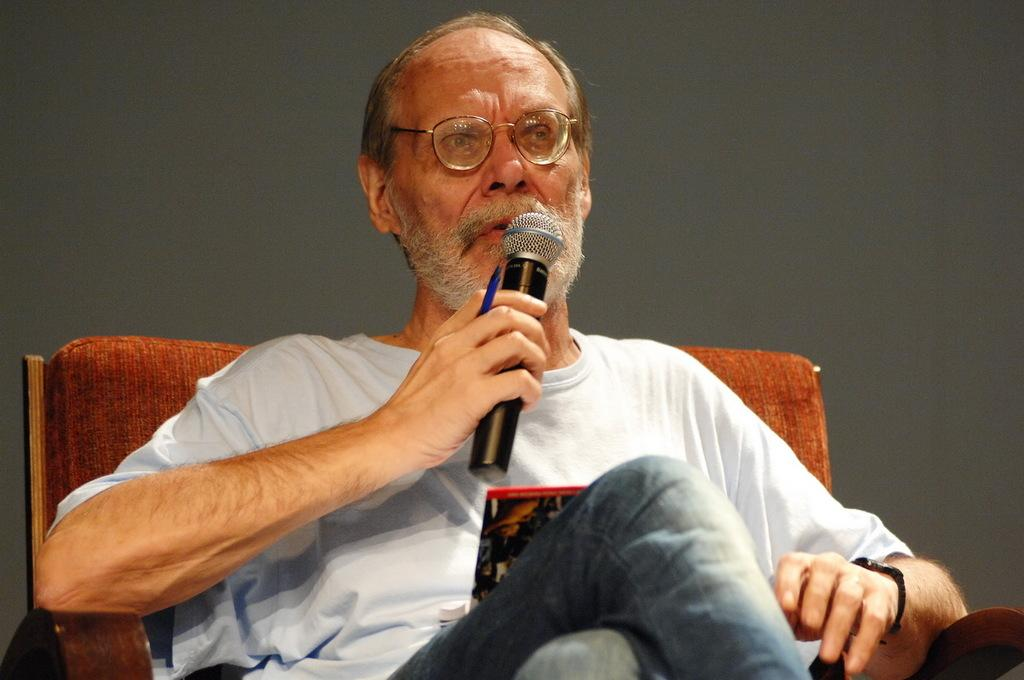What is the main subject of the image? The main subject of the image is a man. What is the man doing in the image? The man is sitting on a chair in the image. What is the man wearing? The man is wearing a white t-shirt and blue jeans. What objects is the man holding in the image? The man is holding a pen and a microphone. What can be seen in the background of the image? There is a wall in the background of the image. Can you tell me how many donkeys are visible in the image? There are no donkeys present in the image. What is the angle of the slope in the image? There is no slope present in the image. 